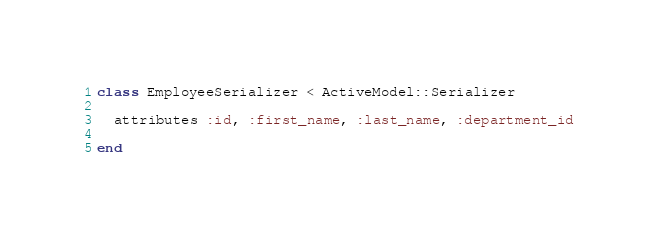Convert code to text. <code><loc_0><loc_0><loc_500><loc_500><_Ruby_>class EmployeeSerializer < ActiveModel::Serializer

  attributes :id, :first_name, :last_name, :department_id
  
end
</code> 